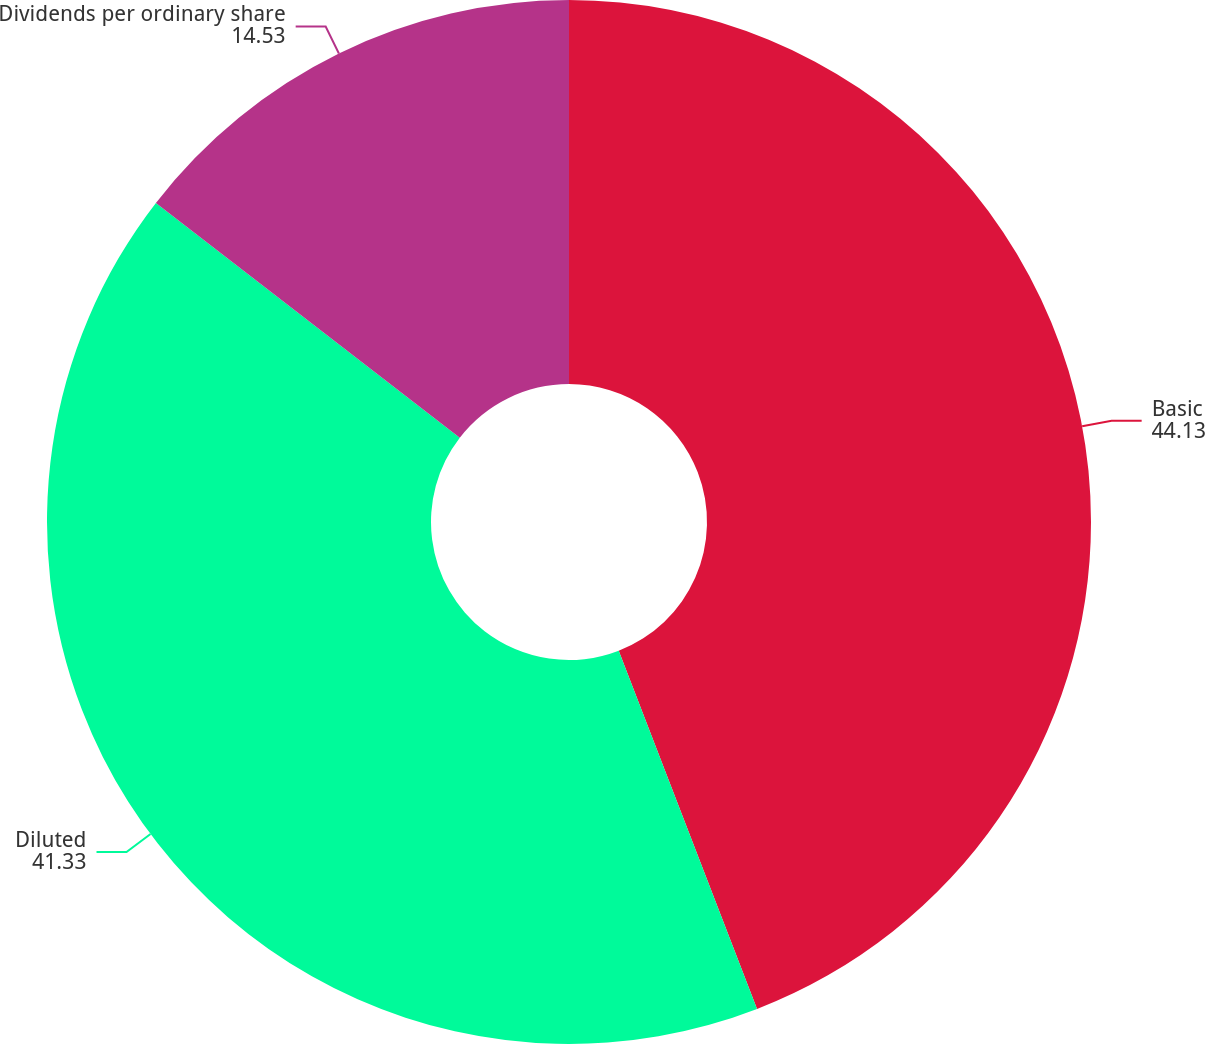Convert chart to OTSL. <chart><loc_0><loc_0><loc_500><loc_500><pie_chart><fcel>Basic<fcel>Diluted<fcel>Dividends per ordinary share<nl><fcel>44.13%<fcel>41.33%<fcel>14.53%<nl></chart> 